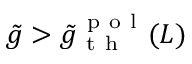<formula> <loc_0><loc_0><loc_500><loc_500>\tilde { g } > \tilde { g } _ { t h } ^ { p o l } ( L )</formula> 